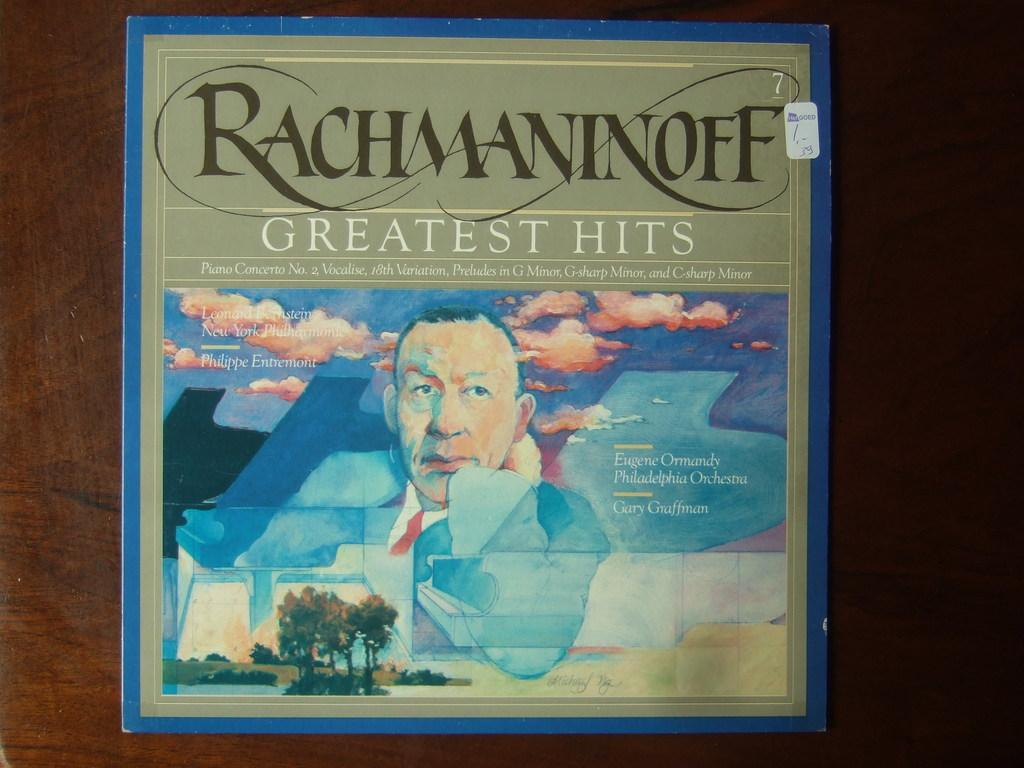Provide a one-sentence caption for the provided image. An album, Rachmaninoff Greatest Hits, on a dark wooden surface. 